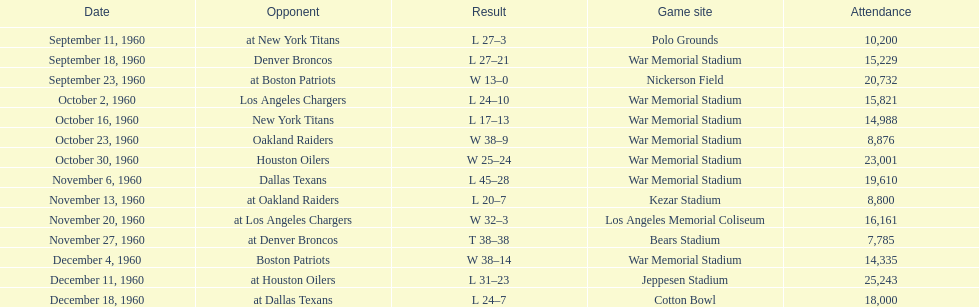Which date had the highest attendance? December 11, 1960. 